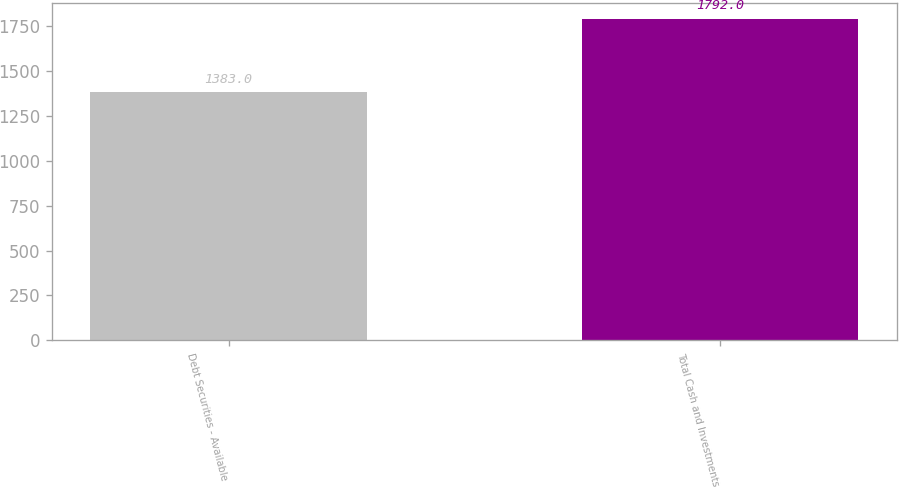<chart> <loc_0><loc_0><loc_500><loc_500><bar_chart><fcel>Debt Securities - Available<fcel>Total Cash and Investments<nl><fcel>1383<fcel>1792<nl></chart> 